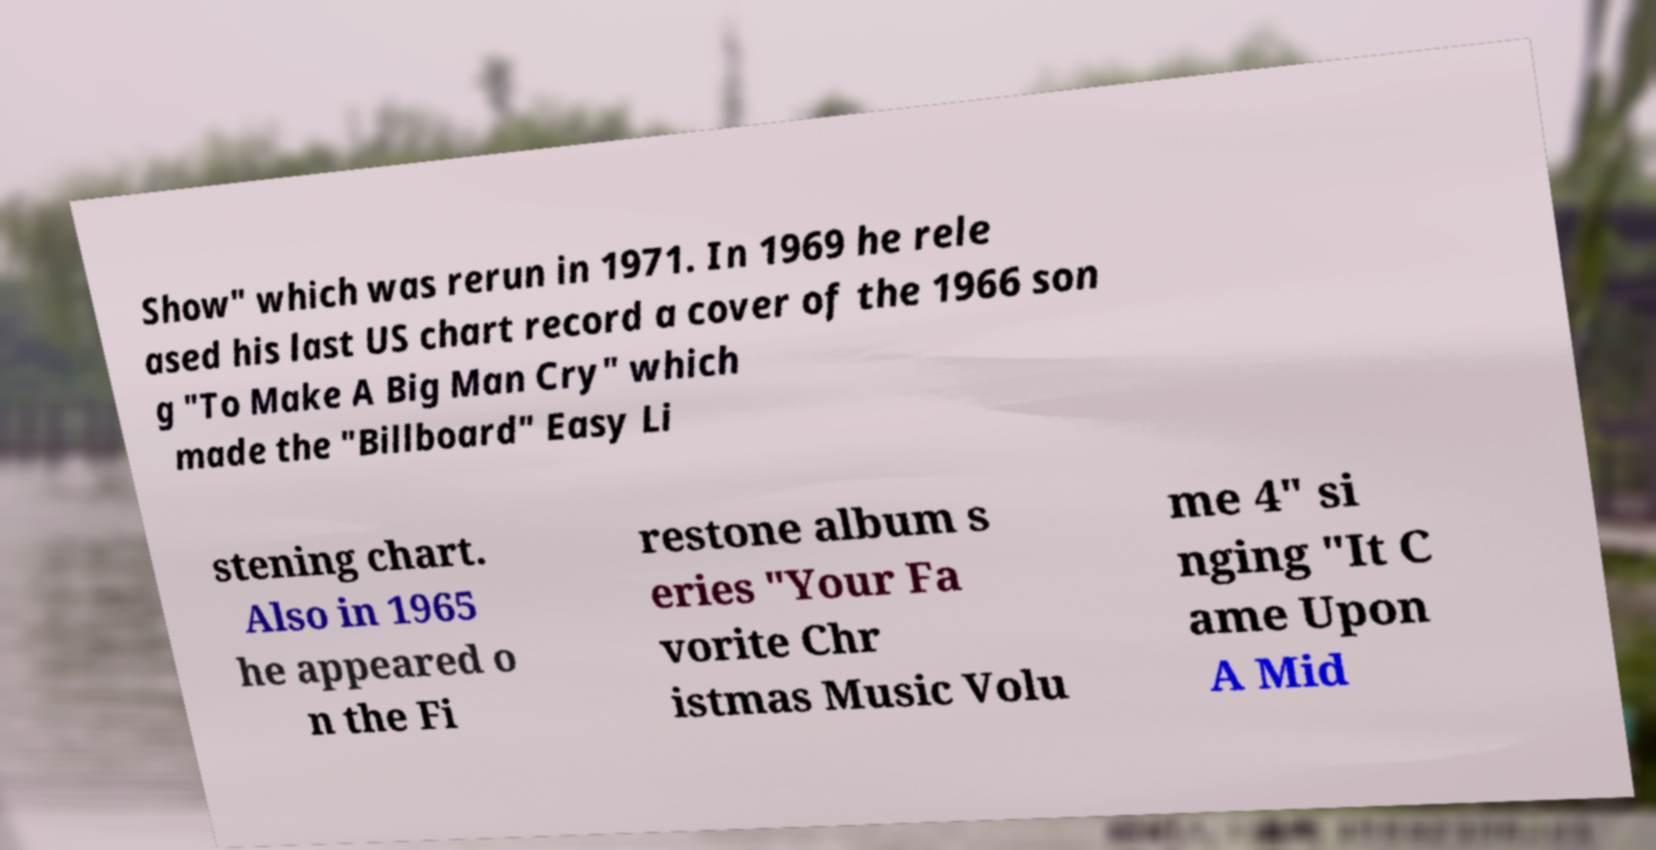Could you extract and type out the text from this image? Show" which was rerun in 1971. In 1969 he rele ased his last US chart record a cover of the 1966 son g "To Make A Big Man Cry" which made the "Billboard" Easy Li stening chart. Also in 1965 he appeared o n the Fi restone album s eries "Your Fa vorite Chr istmas Music Volu me 4" si nging "It C ame Upon A Mid 